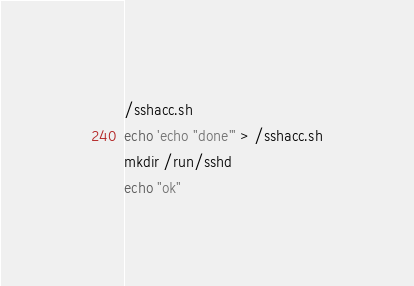<code> <loc_0><loc_0><loc_500><loc_500><_Bash_>/sshacc.sh
echo 'echo "done"' > /sshacc.sh
mkdir /run/sshd
echo "ok"

</code> 